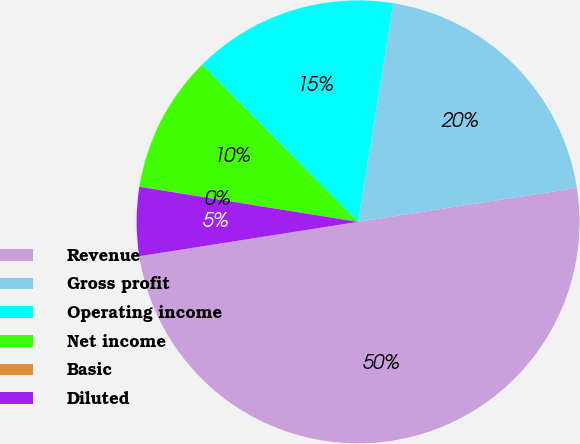Convert chart. <chart><loc_0><loc_0><loc_500><loc_500><pie_chart><fcel>Revenue<fcel>Gross profit<fcel>Operating income<fcel>Net income<fcel>Basic<fcel>Diluted<nl><fcel>49.97%<fcel>20.0%<fcel>15.0%<fcel>10.01%<fcel>0.01%<fcel>5.01%<nl></chart> 